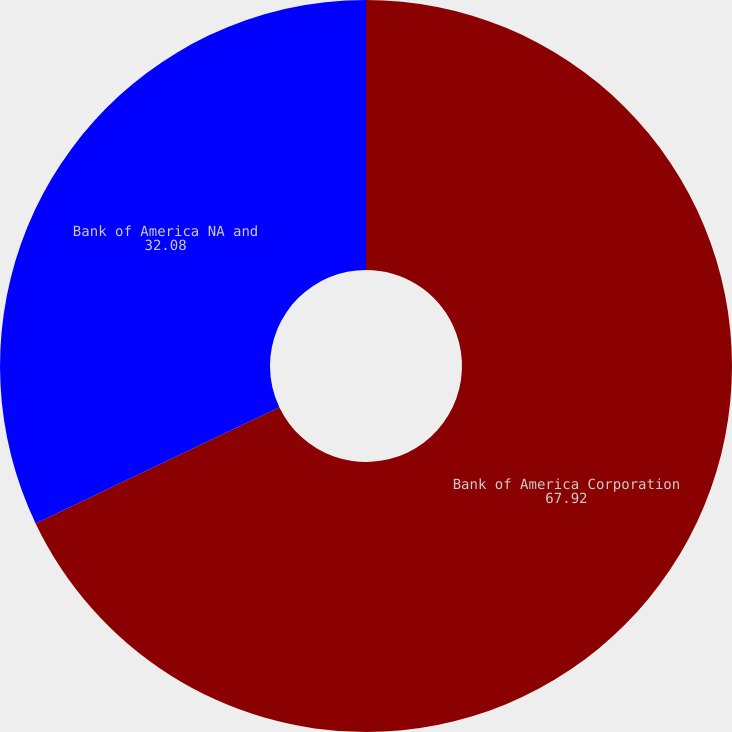<chart> <loc_0><loc_0><loc_500><loc_500><pie_chart><fcel>Bank of America Corporation<fcel>Bank of America NA and<nl><fcel>67.92%<fcel>32.08%<nl></chart> 